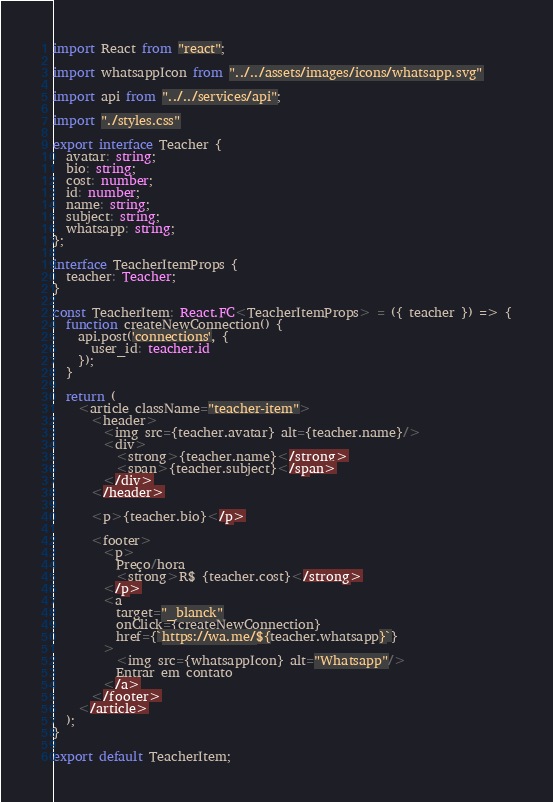<code> <loc_0><loc_0><loc_500><loc_500><_TypeScript_>import React from "react";

import whatsappIcon from "../../assets/images/icons/whatsapp.svg"

import api from "../../services/api";

import "./styles.css"

export interface Teacher {
  avatar: string;
  bio: string;
  cost: number;
  id: number;
  name: string;
  subject: string;
  whatsapp: string;
};

interface TeacherItemProps {
  teacher: Teacher;
}

const TeacherItem: React.FC<TeacherItemProps> = ({ teacher }) => {
  function createNewConnection() {
    api.post('connections', {
      user_id: teacher.id
    });
  }

  return (
    <article className="teacher-item">
      <header>
        <img src={teacher.avatar} alt={teacher.name}/>
        <div>
          <strong>{teacher.name}</strong>
          <span>{teacher.subject}</span>
        </div>
      </header>
      
      <p>{teacher.bio}</p>

      <footer>
        <p>
          Preço/hora
          <strong>R$ {teacher.cost}</strong>
        </p>
        <a 
          target="_blanck"
          onClick={createNewConnection} 
          href={`https://wa.me/${teacher.whatsapp}`}
        >
          <img src={whatsappIcon} alt="Whatsapp"/>
          Entrar em contato
        </a>
      </footer>
    </article>
  );
}

export default TeacherItem;
</code> 